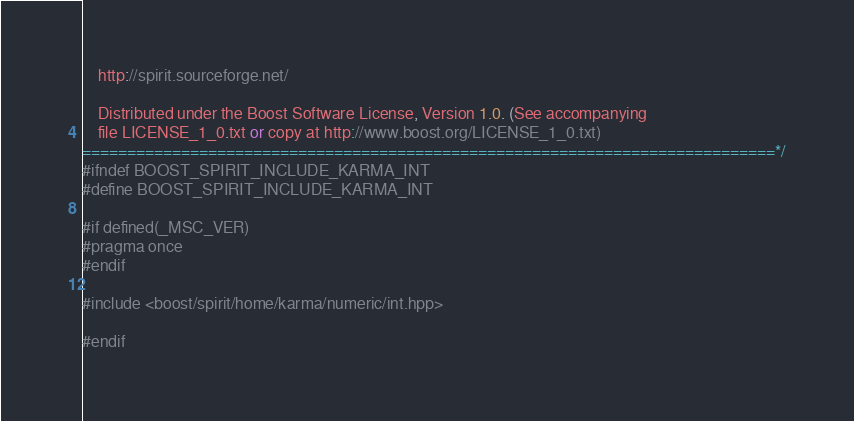<code> <loc_0><loc_0><loc_500><loc_500><_C++_>    http://spirit.sourceforge.net/

    Distributed under the Boost Software License, Version 1.0. (See accompanying
    file LICENSE_1_0.txt or copy at http://www.boost.org/LICENSE_1_0.txt)
=============================================================================*/
#ifndef BOOST_SPIRIT_INCLUDE_KARMA_INT
#define BOOST_SPIRIT_INCLUDE_KARMA_INT

#if defined(_MSC_VER)
#pragma once
#endif

#include <boost/spirit/home/karma/numeric/int.hpp>

#endif
</code> 